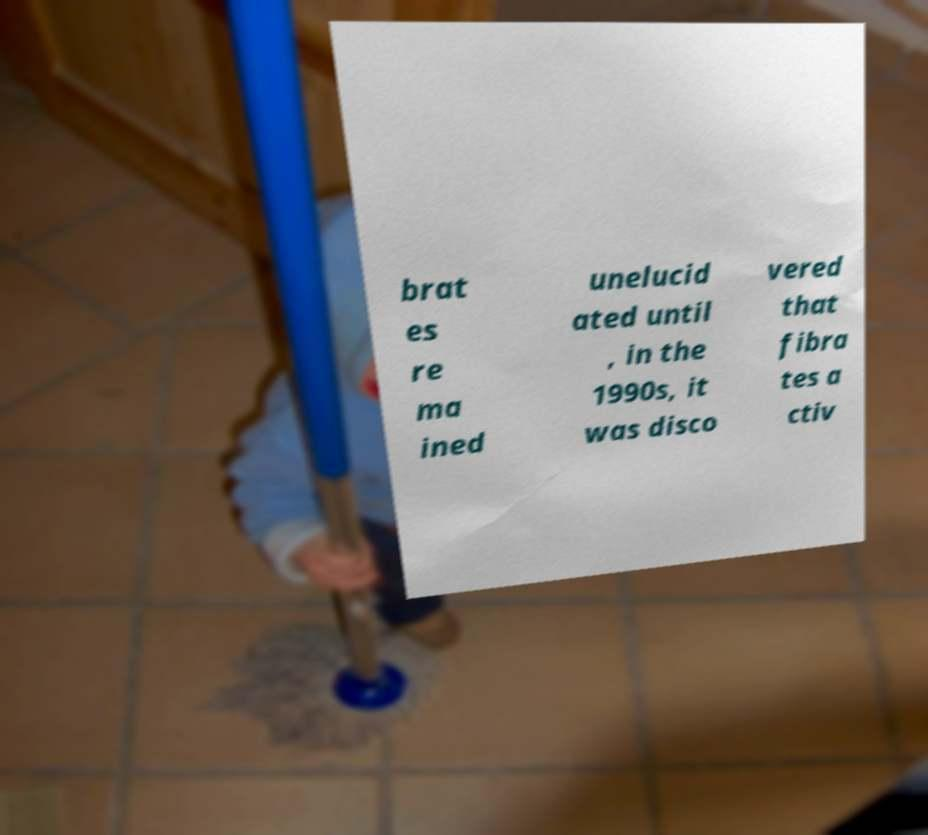I need the written content from this picture converted into text. Can you do that? brat es re ma ined unelucid ated until , in the 1990s, it was disco vered that fibra tes a ctiv 